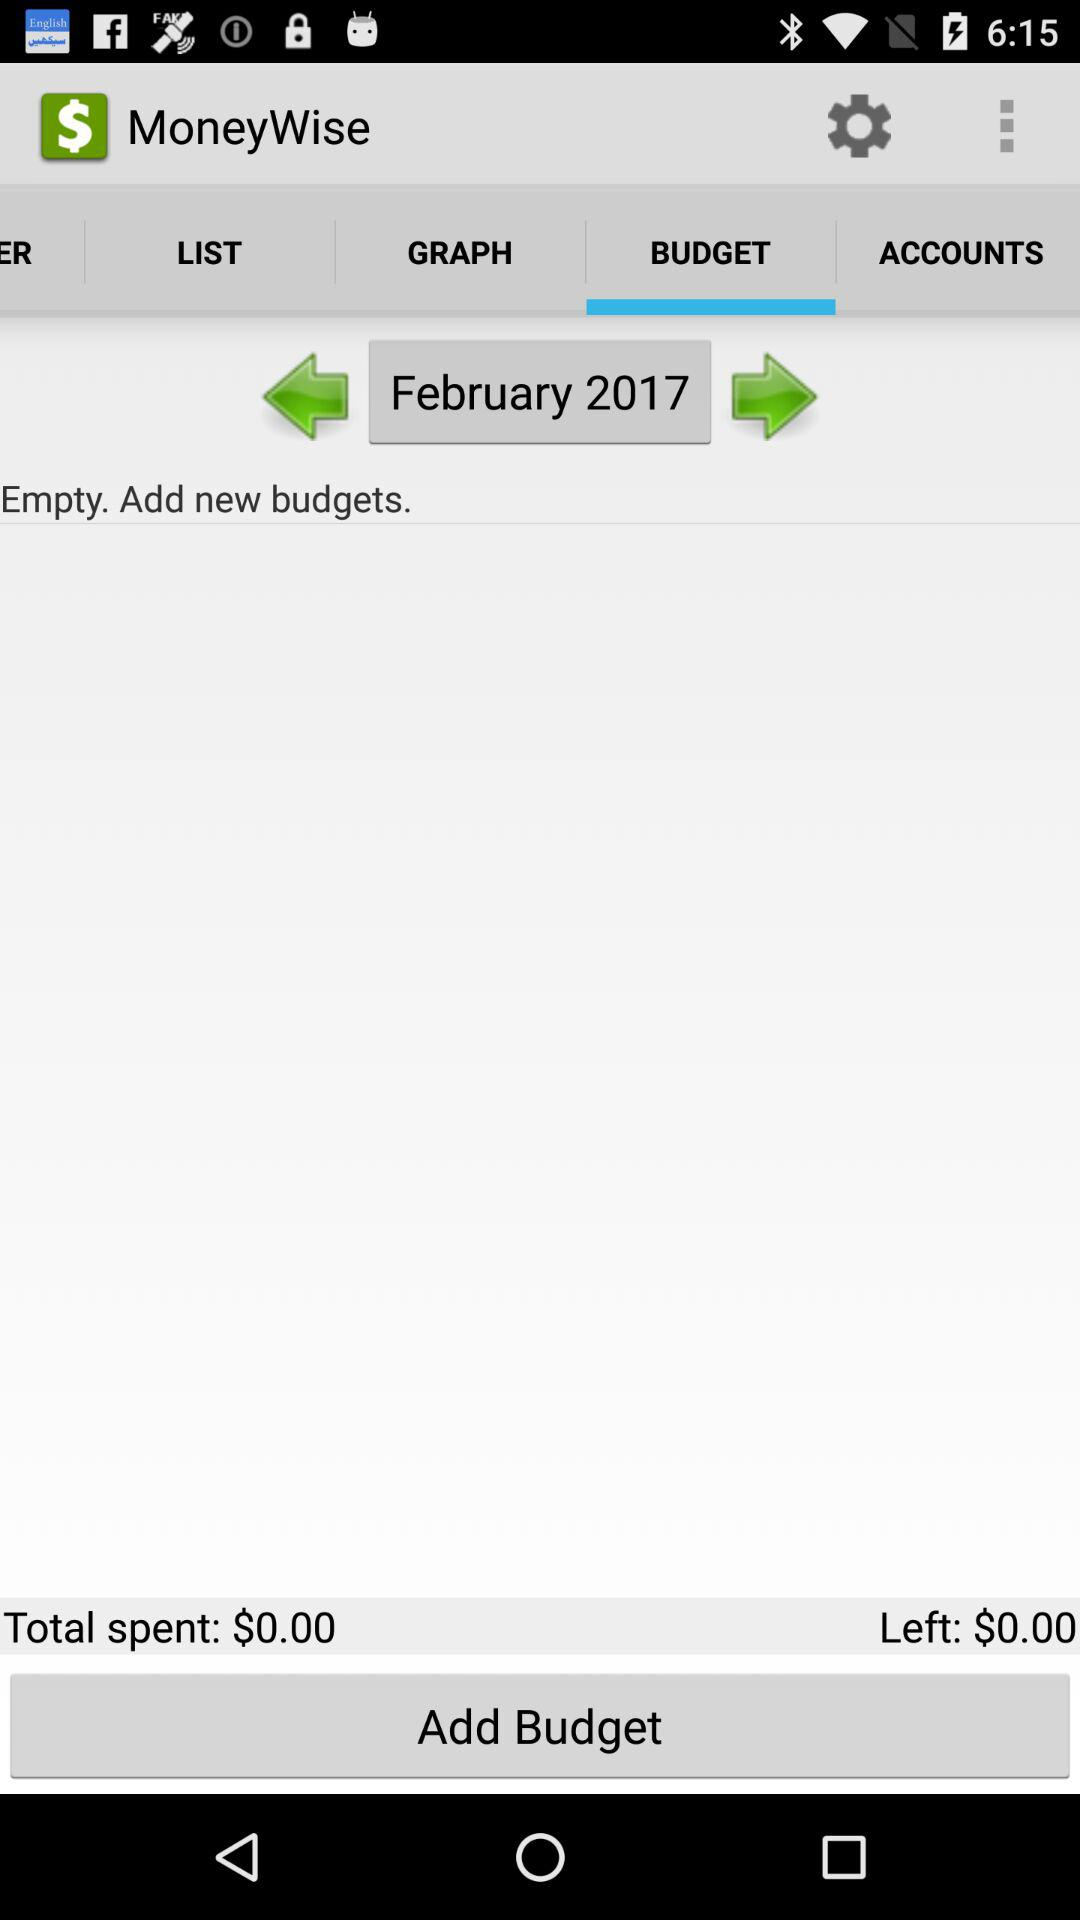How much money do I have left in my budget?
Answer the question using a single word or phrase. $0.00 